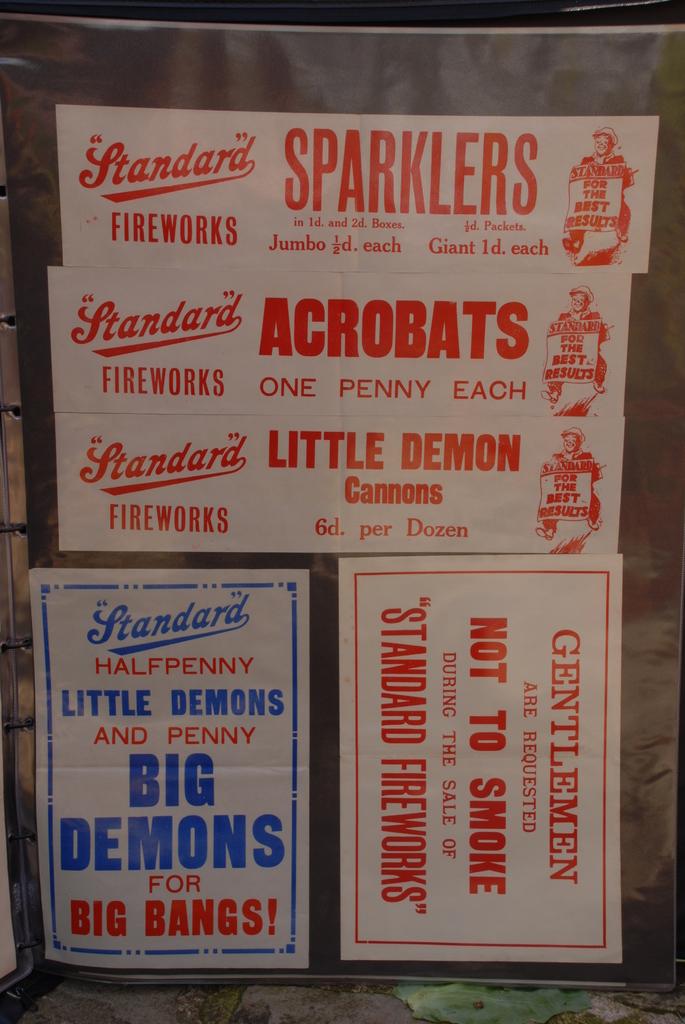What are they advertising?
Provide a succinct answer. Fireworks. How much are acrobats?
Your answer should be compact. One penny each. 